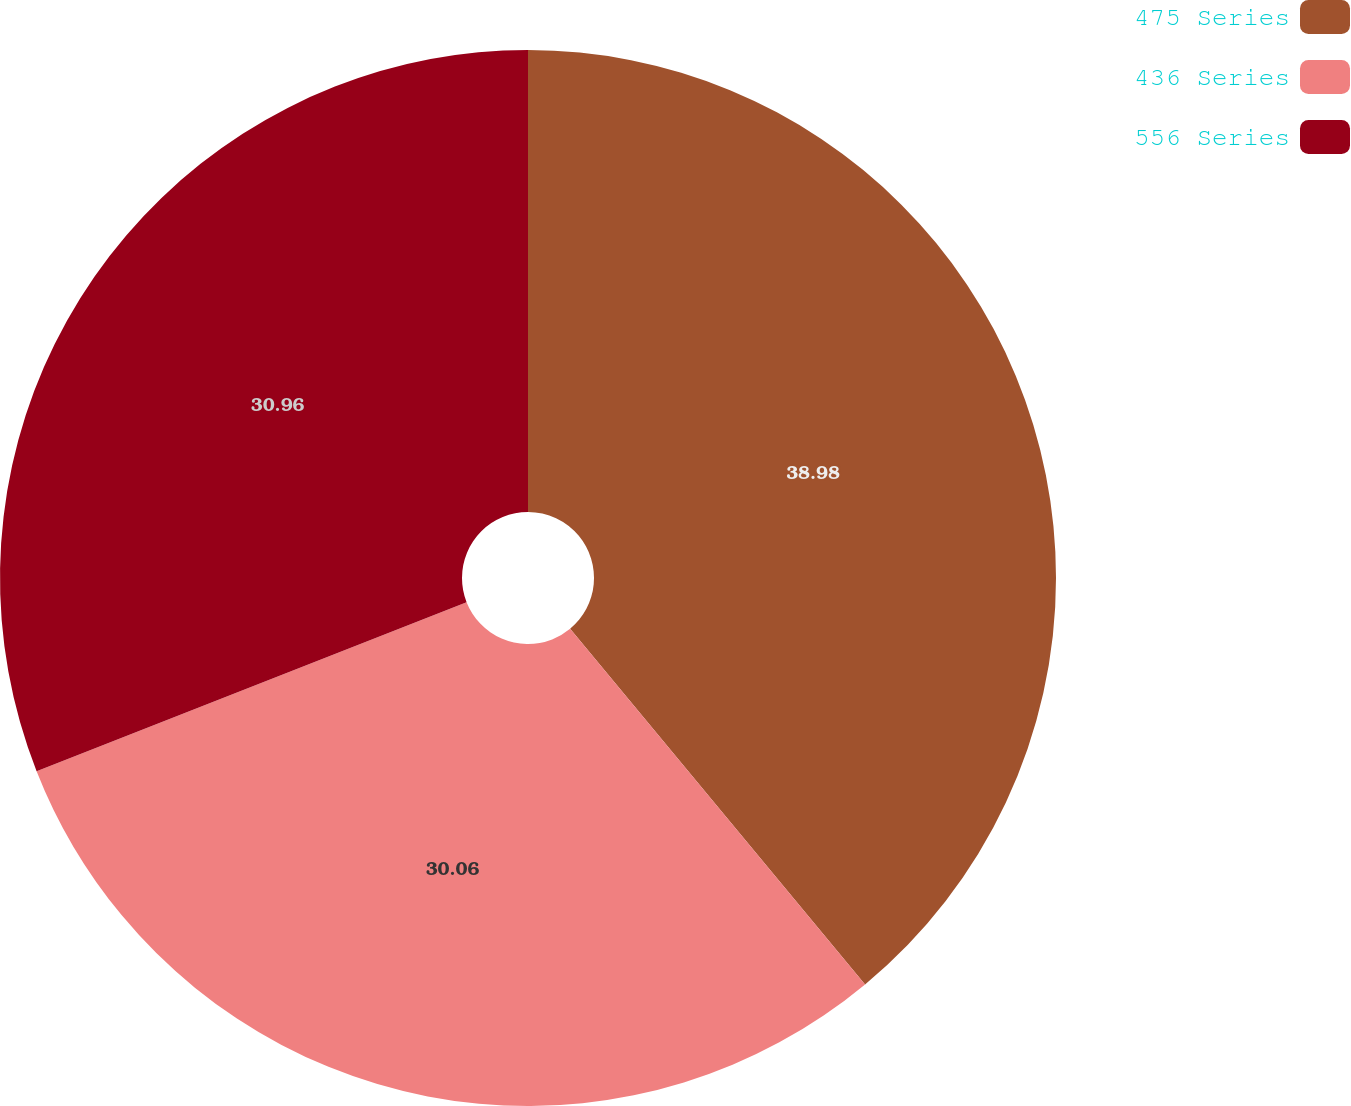Convert chart to OTSL. <chart><loc_0><loc_0><loc_500><loc_500><pie_chart><fcel>475 Series<fcel>436 Series<fcel>556 Series<nl><fcel>38.98%<fcel>30.06%<fcel>30.96%<nl></chart> 